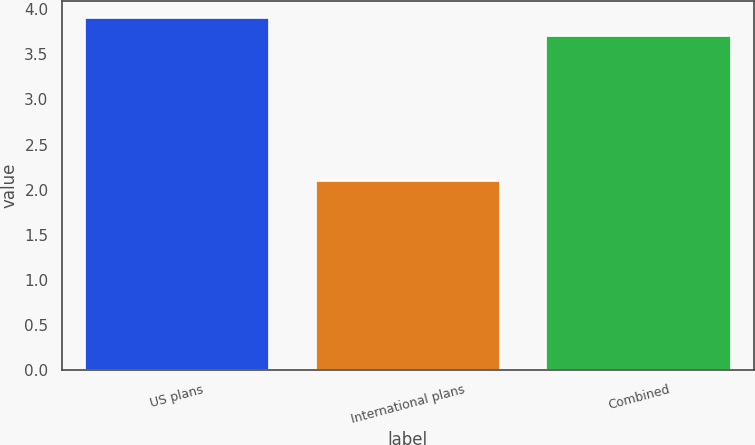<chart> <loc_0><loc_0><loc_500><loc_500><bar_chart><fcel>US plans<fcel>International plans<fcel>Combined<nl><fcel>3.9<fcel>2.1<fcel>3.7<nl></chart> 